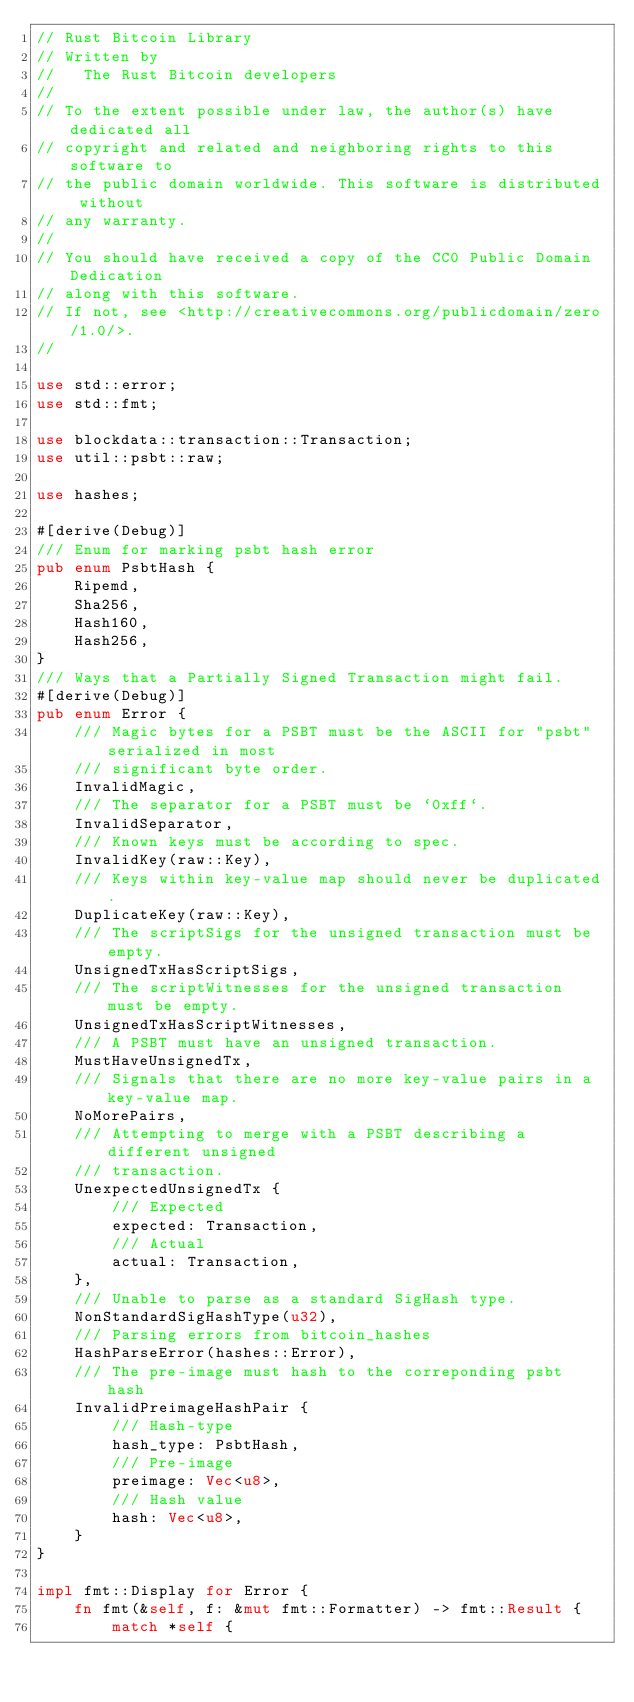<code> <loc_0><loc_0><loc_500><loc_500><_Rust_>// Rust Bitcoin Library
// Written by
//   The Rust Bitcoin developers
//
// To the extent possible under law, the author(s) have dedicated all
// copyright and related and neighboring rights to this software to
// the public domain worldwide. This software is distributed without
// any warranty.
//
// You should have received a copy of the CC0 Public Domain Dedication
// along with this software.
// If not, see <http://creativecommons.org/publicdomain/zero/1.0/>.
//

use std::error;
use std::fmt;

use blockdata::transaction::Transaction;
use util::psbt::raw;

use hashes;

#[derive(Debug)]
/// Enum for marking psbt hash error
pub enum PsbtHash {
    Ripemd,
    Sha256,
    Hash160,
    Hash256,
}
/// Ways that a Partially Signed Transaction might fail.
#[derive(Debug)]
pub enum Error {
    /// Magic bytes for a PSBT must be the ASCII for "psbt" serialized in most
    /// significant byte order.
    InvalidMagic,
    /// The separator for a PSBT must be `0xff`.
    InvalidSeparator,
    /// Known keys must be according to spec.
    InvalidKey(raw::Key),
    /// Keys within key-value map should never be duplicated.
    DuplicateKey(raw::Key),
    /// The scriptSigs for the unsigned transaction must be empty.
    UnsignedTxHasScriptSigs,
    /// The scriptWitnesses for the unsigned transaction must be empty.
    UnsignedTxHasScriptWitnesses,
    /// A PSBT must have an unsigned transaction.
    MustHaveUnsignedTx,
    /// Signals that there are no more key-value pairs in a key-value map.
    NoMorePairs,
    /// Attempting to merge with a PSBT describing a different unsigned
    /// transaction.
    UnexpectedUnsignedTx {
        /// Expected
        expected: Transaction,
        /// Actual
        actual: Transaction,
    },
    /// Unable to parse as a standard SigHash type.
    NonStandardSigHashType(u32),
    /// Parsing errors from bitcoin_hashes
    HashParseError(hashes::Error),
    /// The pre-image must hash to the correponding psbt hash
    InvalidPreimageHashPair {
        /// Hash-type
        hash_type: PsbtHash,
        /// Pre-image
        preimage: Vec<u8>,
        /// Hash value
        hash: Vec<u8>,
    }
}

impl fmt::Display for Error {
    fn fmt(&self, f: &mut fmt::Formatter) -> fmt::Result {
        match *self {</code> 